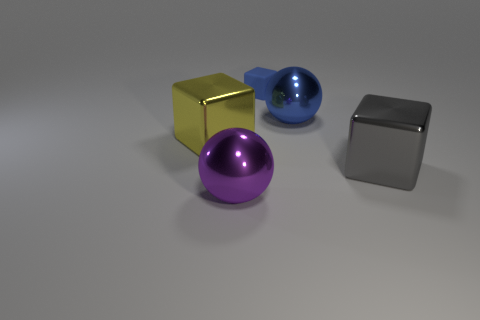How many blue matte objects are the same shape as the large gray object?
Your response must be concise. 1. What color is the ball that is in front of the big sphere right of the small blue object?
Provide a short and direct response. Purple. Is the number of large metallic cubes that are on the right side of the purple metal thing the same as the number of tiny blue balls?
Provide a succinct answer. No. Is there another blue object of the same size as the rubber thing?
Your answer should be compact. No. There is a blue sphere; does it have the same size as the yellow block that is in front of the tiny blue rubber thing?
Ensure brevity in your answer.  Yes. Is the number of gray shiny blocks that are left of the yellow thing the same as the number of large spheres that are in front of the large purple sphere?
Keep it short and to the point. Yes. What shape is the metal object that is the same color as the tiny matte cube?
Your response must be concise. Sphere. What material is the big ball that is in front of the yellow shiny block?
Your answer should be compact. Metal. Do the blue matte block and the blue shiny thing have the same size?
Give a very brief answer. No. Is the number of tiny blue matte blocks right of the large gray metal block greater than the number of brown matte cylinders?
Offer a very short reply. No. 